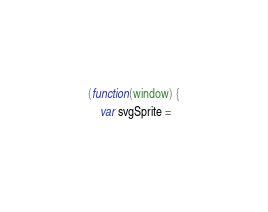<code> <loc_0><loc_0><loc_500><loc_500><_JavaScript_>(function(window) {
    var svgSprite =</code> 